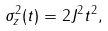<formula> <loc_0><loc_0><loc_500><loc_500>\sigma _ { z } ^ { 2 } ( t ) = 2 J ^ { 2 } t ^ { 2 } ,</formula> 